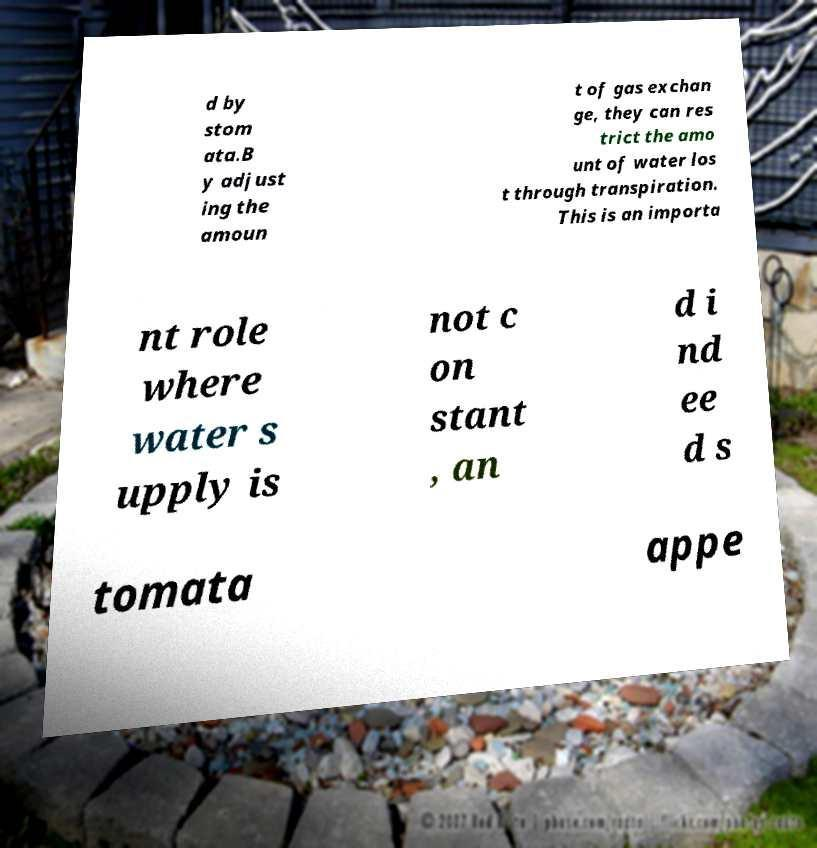Please identify and transcribe the text found in this image. d by stom ata.B y adjust ing the amoun t of gas exchan ge, they can res trict the amo unt of water los t through transpiration. This is an importa nt role where water s upply is not c on stant , an d i nd ee d s tomata appe 